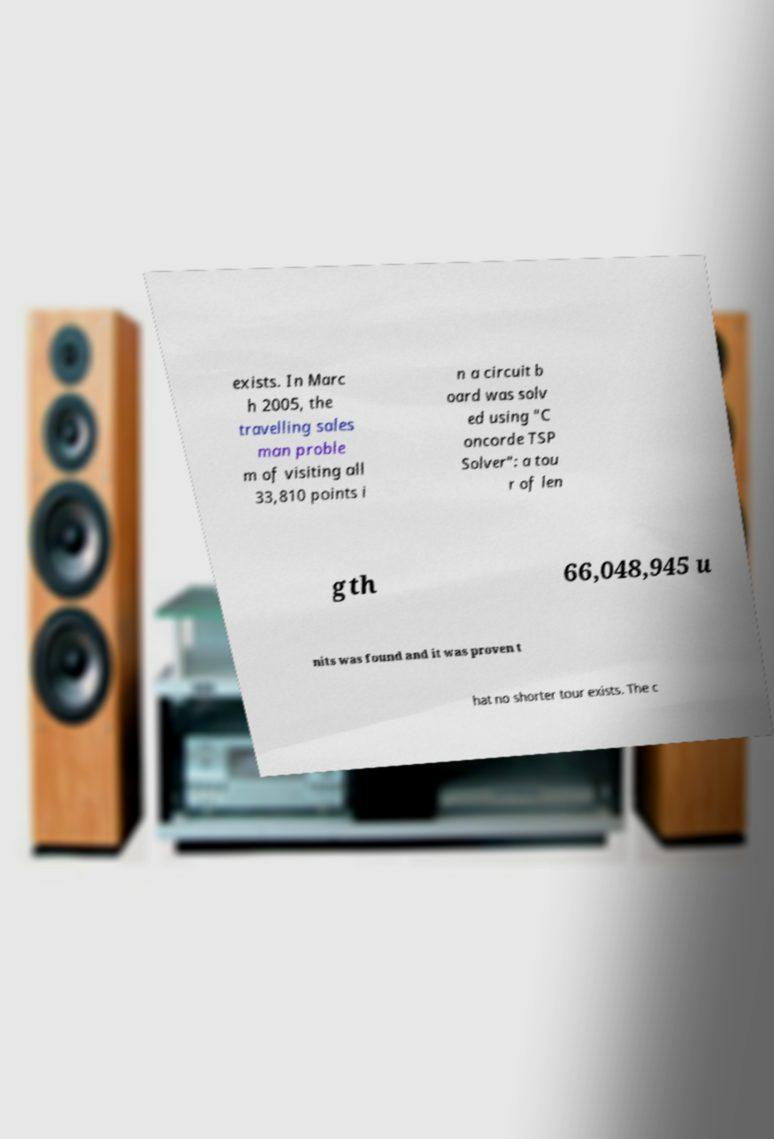Could you extract and type out the text from this image? exists. In Marc h 2005, the travelling sales man proble m of visiting all 33,810 points i n a circuit b oard was solv ed using "C oncorde TSP Solver": a tou r of len gth 66,048,945 u nits was found and it was proven t hat no shorter tour exists. The c 